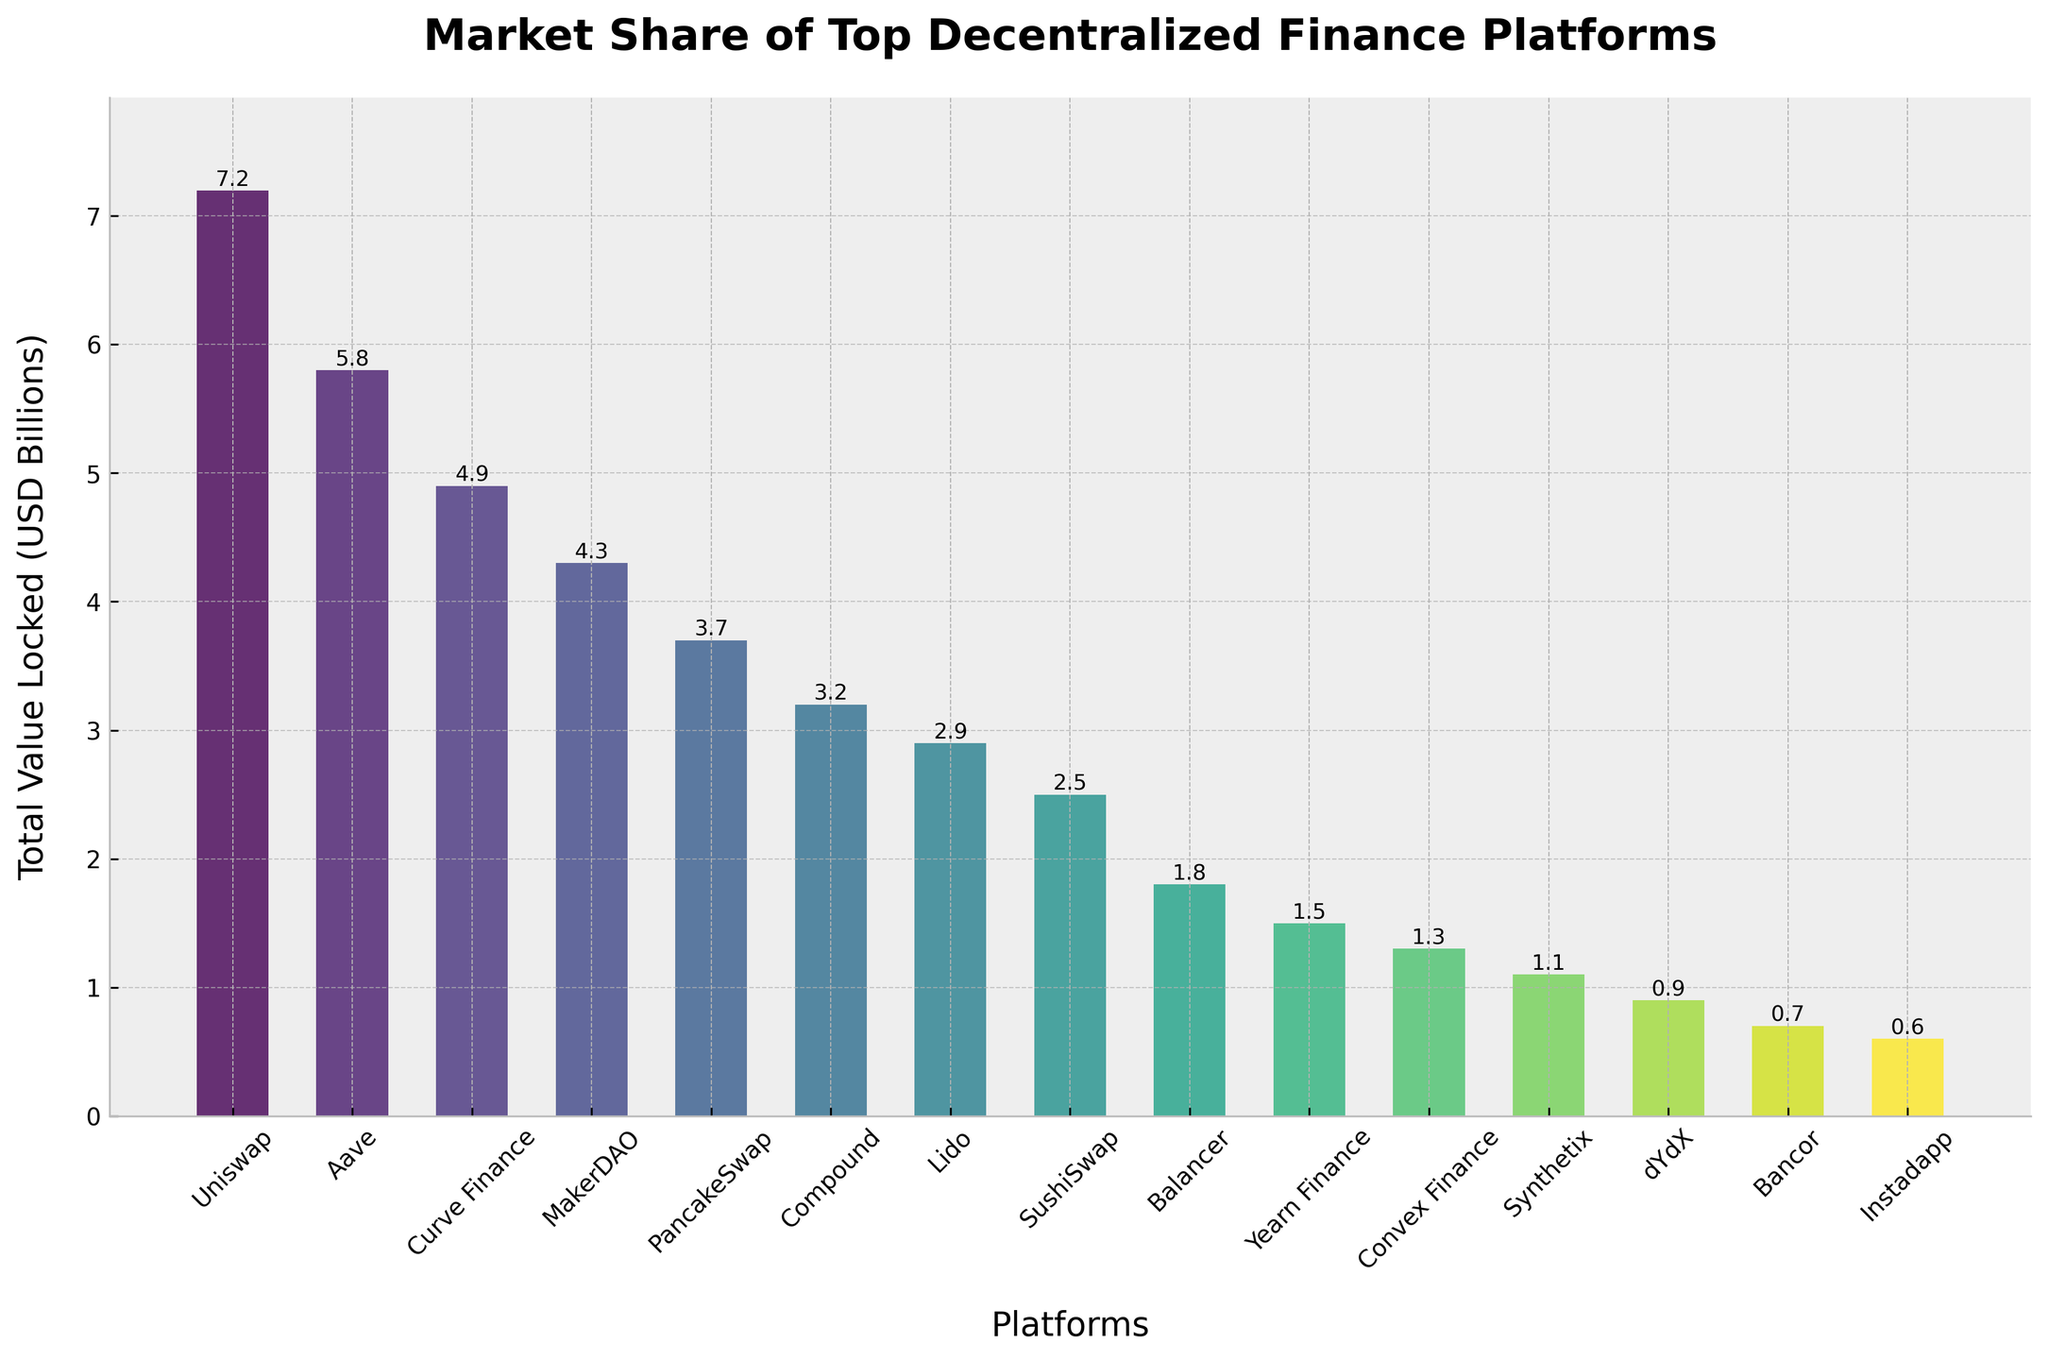Which platform has the highest total value locked? Uniswap has the highest bar representing its Total Value Locked, indicating it has the most value locked among the platforms.
Answer: Uniswap Which platform has the lowest total value locked? Instadapp has the smallest bar indicating its Total Value Locked, making it the lowest among the platforms.
Answer: Instadapp By how much is Uniswap's total value locked greater than Aave's? Uniswap has a Total Value Locked of 7.2 billion USD, and Aave has 5.8 billion USD. The difference is 7.2 - 5.8 = 1.4 billion USD.
Answer: 1.4 billion USD What is the total value locked in the top three platforms combined? The top three platforms are Uniswap, Aave, and Curve Finance. Their Total Values Locked are 7.2, 5.8, and 4.9 billion USD respectively. The combined value is 7.2 + 5.8 + 4.9 = 17.9 billion USD.
Answer: 17.9 billion USD Which platforms have a total value locked between 2 and 4 billion USD? The platforms with values in this range are Compound (3.2), Lido (2.9), and SushiSwap (2.5).
Answer: Compound, Lido, SushiSwap How many platforms have a total value locked greater than 4 billion USD? The platforms with values greater than 4 billion USD are Uniswap, Aave, Curve Finance, and MakerDAO. Counting these platforms gives us 4.
Answer: 4 Is the total value locked in Synthetix lower than that in SushiSwap? Yes, Synthetix has a Total Value Locked of 1.1 billion USD, while SushiSwap has 2.5 billion USD. Comparing these values, Synthetix is lower.
Answer: Yes What is the median total value locked among all listed platforms? The Total Values Locked in ascending order are 0.6, 0.7, 0.9, 1.1, 1.3, 1.5, 1.8, 2.5, 2.9, 3.2, 3.7, 4.3, 4.9, 5.8, 7.2. The median is the middle value, which is 2.5 billion USD.
Answer: 2.5 billion USD Which platform has a total value locked closest to 2 billion USD? Balancer has a Total Value Locked of 1.8 billion USD, which is the closest to 2 billion.
Answer: Balancer 